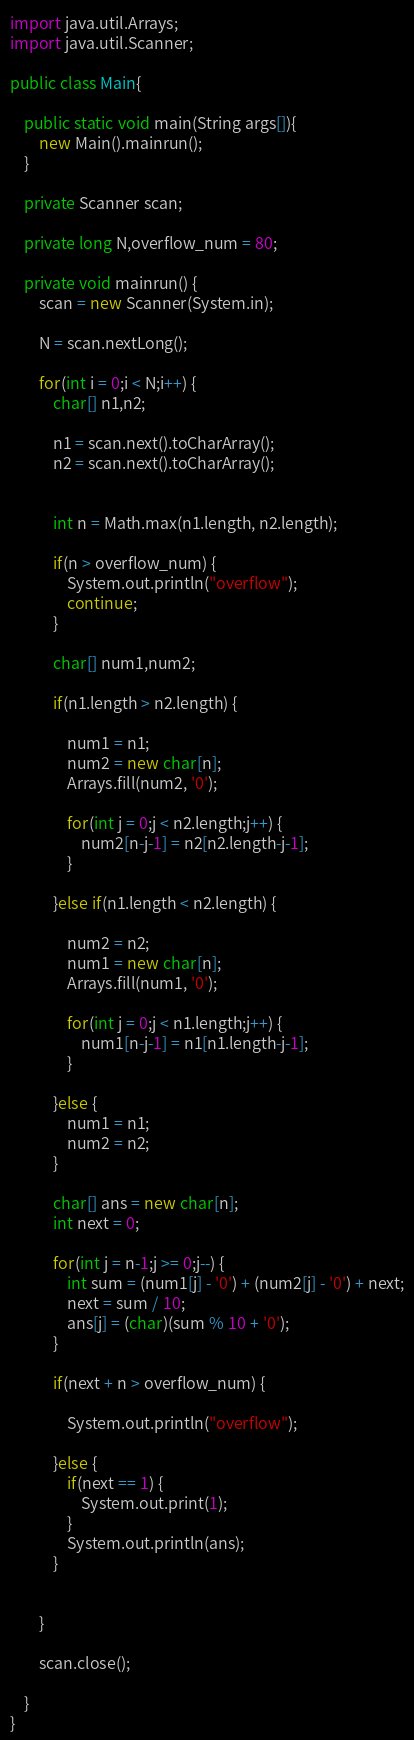Convert code to text. <code><loc_0><loc_0><loc_500><loc_500><_Java_>import java.util.Arrays;
import java.util.Scanner;

public class Main{

	public static void main(String args[]){
		new Main().mainrun();
	}

	private Scanner scan;

	private long N,overflow_num = 80;

	private void mainrun() {
		scan = new Scanner(System.in);

		N = scan.nextLong();

		for(int i = 0;i < N;i++) {
			char[] n1,n2;

			n1 = scan.next().toCharArray();
			n2 = scan.next().toCharArray();


			int n = Math.max(n1.length, n2.length);

			if(n > overflow_num) {
				System.out.println("overflow");
				continue;
			}

			char[] num1,num2;

			if(n1.length > n2.length) {

				num1 = n1;
				num2 = new char[n];
				Arrays.fill(num2, '0');

				for(int j = 0;j < n2.length;j++) {
					num2[n-j-1] = n2[n2.length-j-1];
				}

			}else if(n1.length < n2.length) {

				num2 = n2;
				num1 = new char[n];
				Arrays.fill(num1, '0');

				for(int j = 0;j < n1.length;j++) {
					num1[n-j-1] = n1[n1.length-j-1];
				}

			}else {
				num1 = n1;
				num2 = n2;
			}

			char[] ans = new char[n];
			int next = 0;

			for(int j = n-1;j >= 0;j--) {
				int sum = (num1[j] - '0') + (num2[j] - '0') + next;
				next = sum / 10;
				ans[j] = (char)(sum % 10 + '0');
			}

			if(next + n > overflow_num) {

				System.out.println("overflow");

			}else {
				if(next == 1) {
					System.out.print(1);
				}
				System.out.println(ans);
			}


		}

		scan.close();

	}
}
</code> 